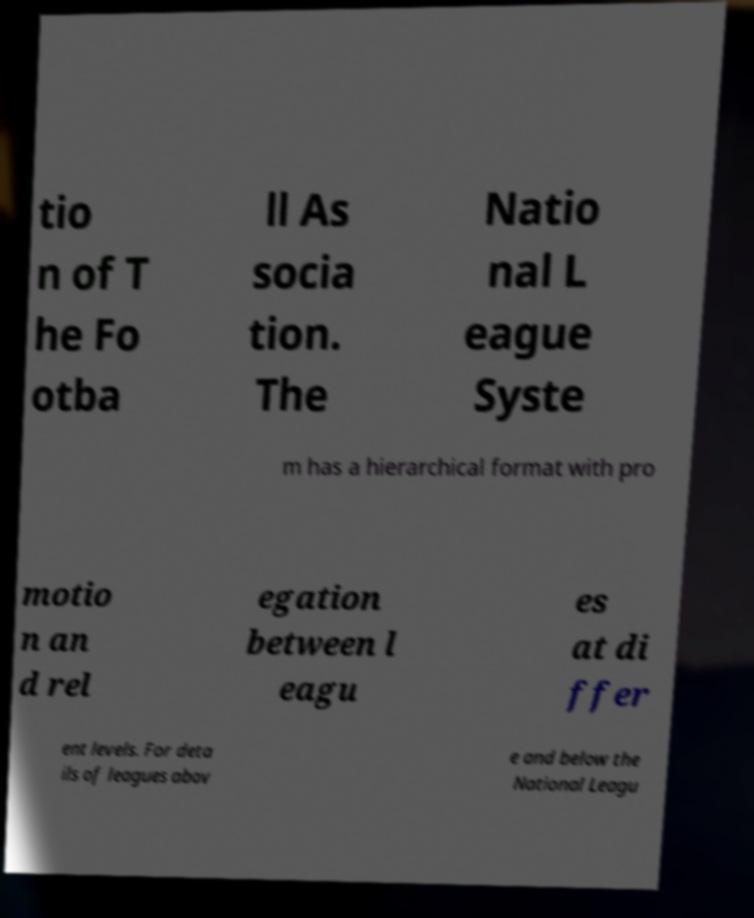I need the written content from this picture converted into text. Can you do that? tio n of T he Fo otba ll As socia tion. The Natio nal L eague Syste m has a hierarchical format with pro motio n an d rel egation between l eagu es at di ffer ent levels. For deta ils of leagues abov e and below the National Leagu 